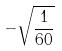<formula> <loc_0><loc_0><loc_500><loc_500>- \sqrt { \frac { 1 } { 6 0 } }</formula> 